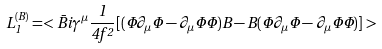Convert formula to latex. <formula><loc_0><loc_0><loc_500><loc_500>L _ { 1 } ^ { ( B ) } = < \bar { B } i \gamma ^ { \mu } \frac { 1 } { 4 f ^ { 2 } } [ ( \Phi \partial _ { \mu } \Phi - \partial _ { \mu } \Phi \Phi ) B - B ( \Phi \partial _ { \mu } \Phi - \partial _ { \mu } \Phi \Phi ) ] ></formula> 